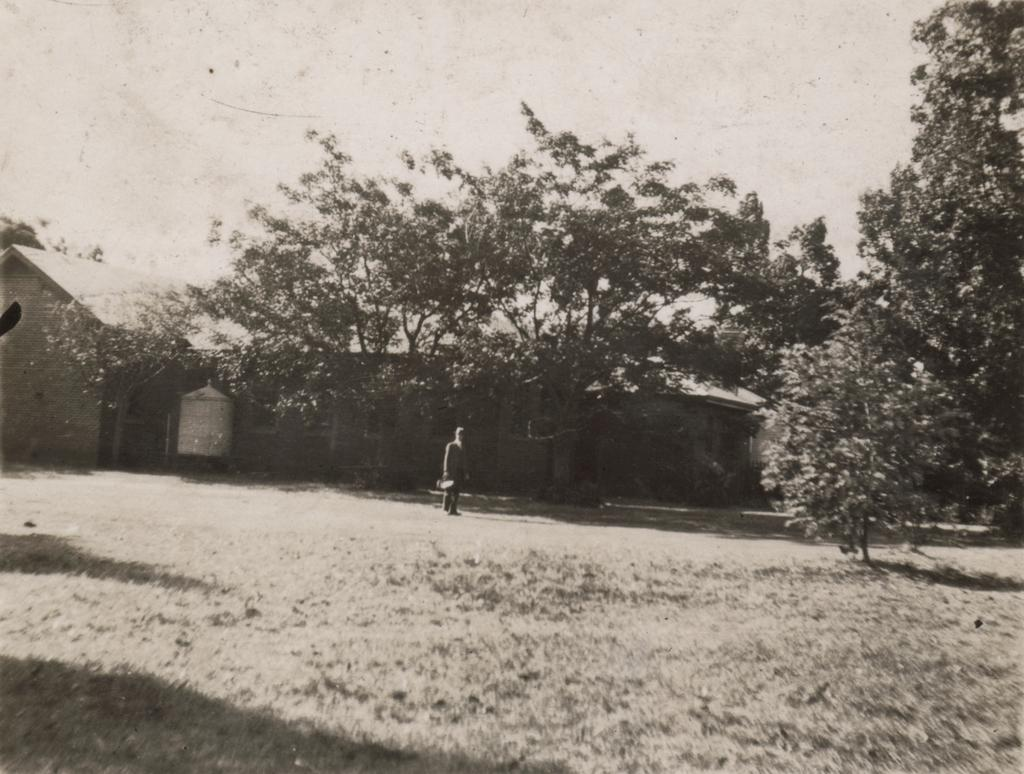What is the color scheme of the image? The image is black and white. What can be seen on the ground in the image? There is a person standing on the ground in the image. What type of structure is present in the image? There is a house in the image. What type of vegetation is visible in the image? There are trees in the image. What is visible in the background of the image? The sky is visible in the background of the image. Where is the throne located in the image? There is no throne present in the image. What type of playground equipment can be seen in the image? There is no playground equipment present in the image. 